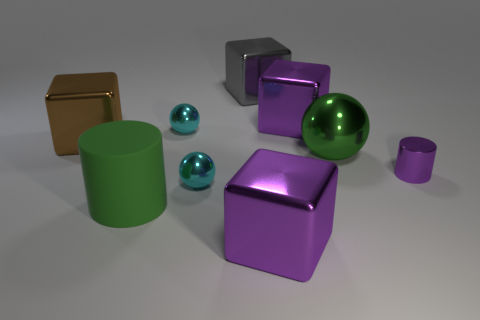What number of metallic things are either small red spheres or balls?
Make the answer very short. 3. Is there any other thing that is the same material as the purple cylinder?
Your response must be concise. Yes. Do the large matte object and the small object that is behind the large sphere have the same color?
Ensure brevity in your answer.  No. There is a green metallic thing; what shape is it?
Your response must be concise. Sphere. What size is the purple cylinder in front of the big purple shiny block that is behind the cyan shiny sphere that is in front of the shiny cylinder?
Offer a terse response. Small. What number of other objects are there of the same shape as the big green matte thing?
Make the answer very short. 1. There is a large shiny thing that is in front of the large sphere; is its shape the same as the tiny shiny object behind the big green ball?
Make the answer very short. No. How many cubes are small purple objects or matte objects?
Offer a very short reply. 0. What is the material of the cyan object right of the tiny cyan thing behind the object to the left of the green matte cylinder?
Your answer should be compact. Metal. What number of other things are the same size as the matte cylinder?
Offer a terse response. 5. 